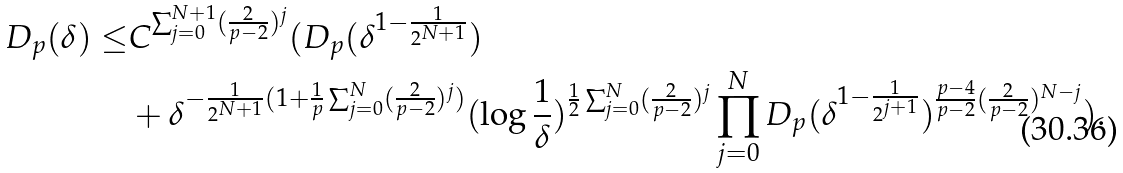<formula> <loc_0><loc_0><loc_500><loc_500>D _ { p } ( \delta ) \leq & C ^ { \sum _ { j = 0 } ^ { N + 1 } ( \frac { 2 } { p - 2 } ) ^ { j } } ( D _ { p } ( \delta ^ { 1 - \frac { 1 } { 2 ^ { N + 1 } } } ) \\ & + \delta ^ { - \frac { 1 } { 2 ^ { N + 1 } } ( 1 + \frac { 1 } { p } \sum _ { j = 0 } ^ { N } ( \frac { 2 } { p - 2 } ) ^ { j } ) } ( \log \frac { 1 } { \delta } ) ^ { \frac { 1 } { 2 } \sum _ { j = 0 } ^ { N } ( \frac { 2 } { p - 2 } ) ^ { j } } \prod _ { j = 0 } ^ { N } D _ { p } ( \delta ^ { 1 - \frac { 1 } { 2 ^ { j + 1 } } } ) ^ { \frac { p - 4 } { p - 2 } ( \frac { 2 } { p - 2 } ) ^ { N - j } } ) .</formula> 